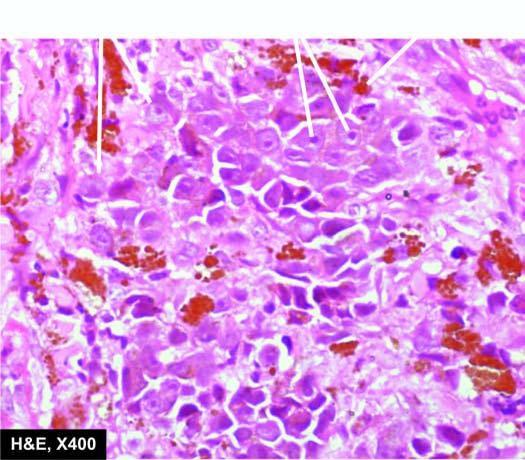s section of the myocardium epithelioid in appearance having prominent nucleoli and contain black finely granular melanin pigment in the cytoplasm?
Answer the question using a single word or phrase. No 